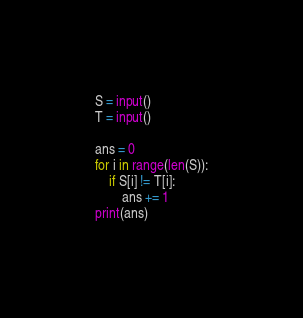Convert code to text. <code><loc_0><loc_0><loc_500><loc_500><_Python_>S = input()
T = input()

ans = 0
for i in range(len(S)):
    if S[i] != T[i]:
        ans += 1
print(ans)</code> 